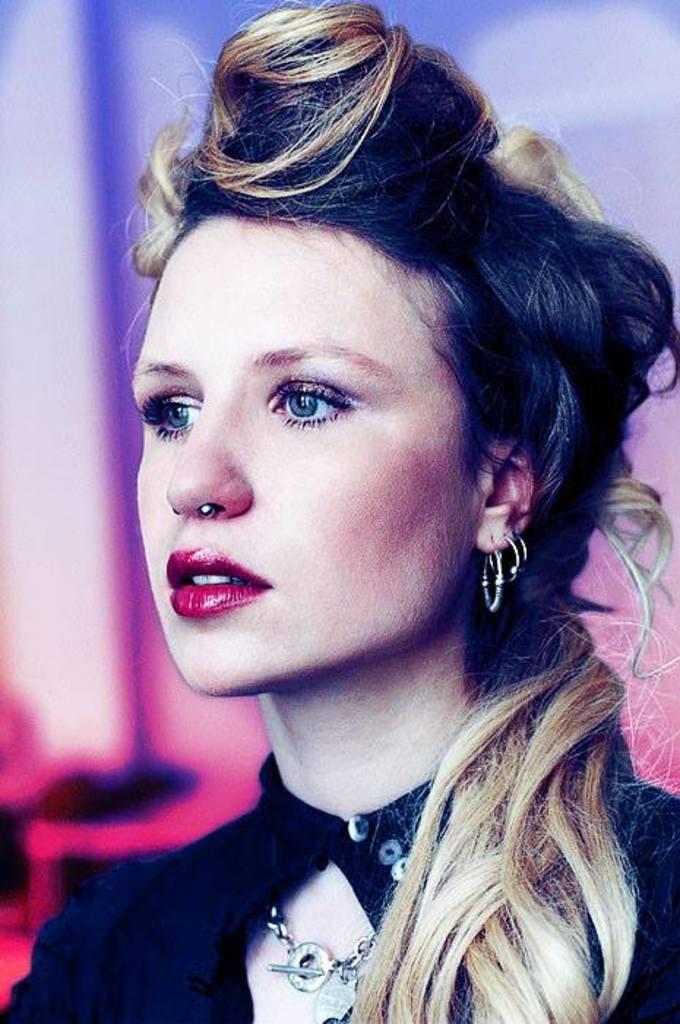In one or two sentences, can you explain what this image depicts? This picture shows a woman. We see earrings to the ear and she wore a black color clothes. 